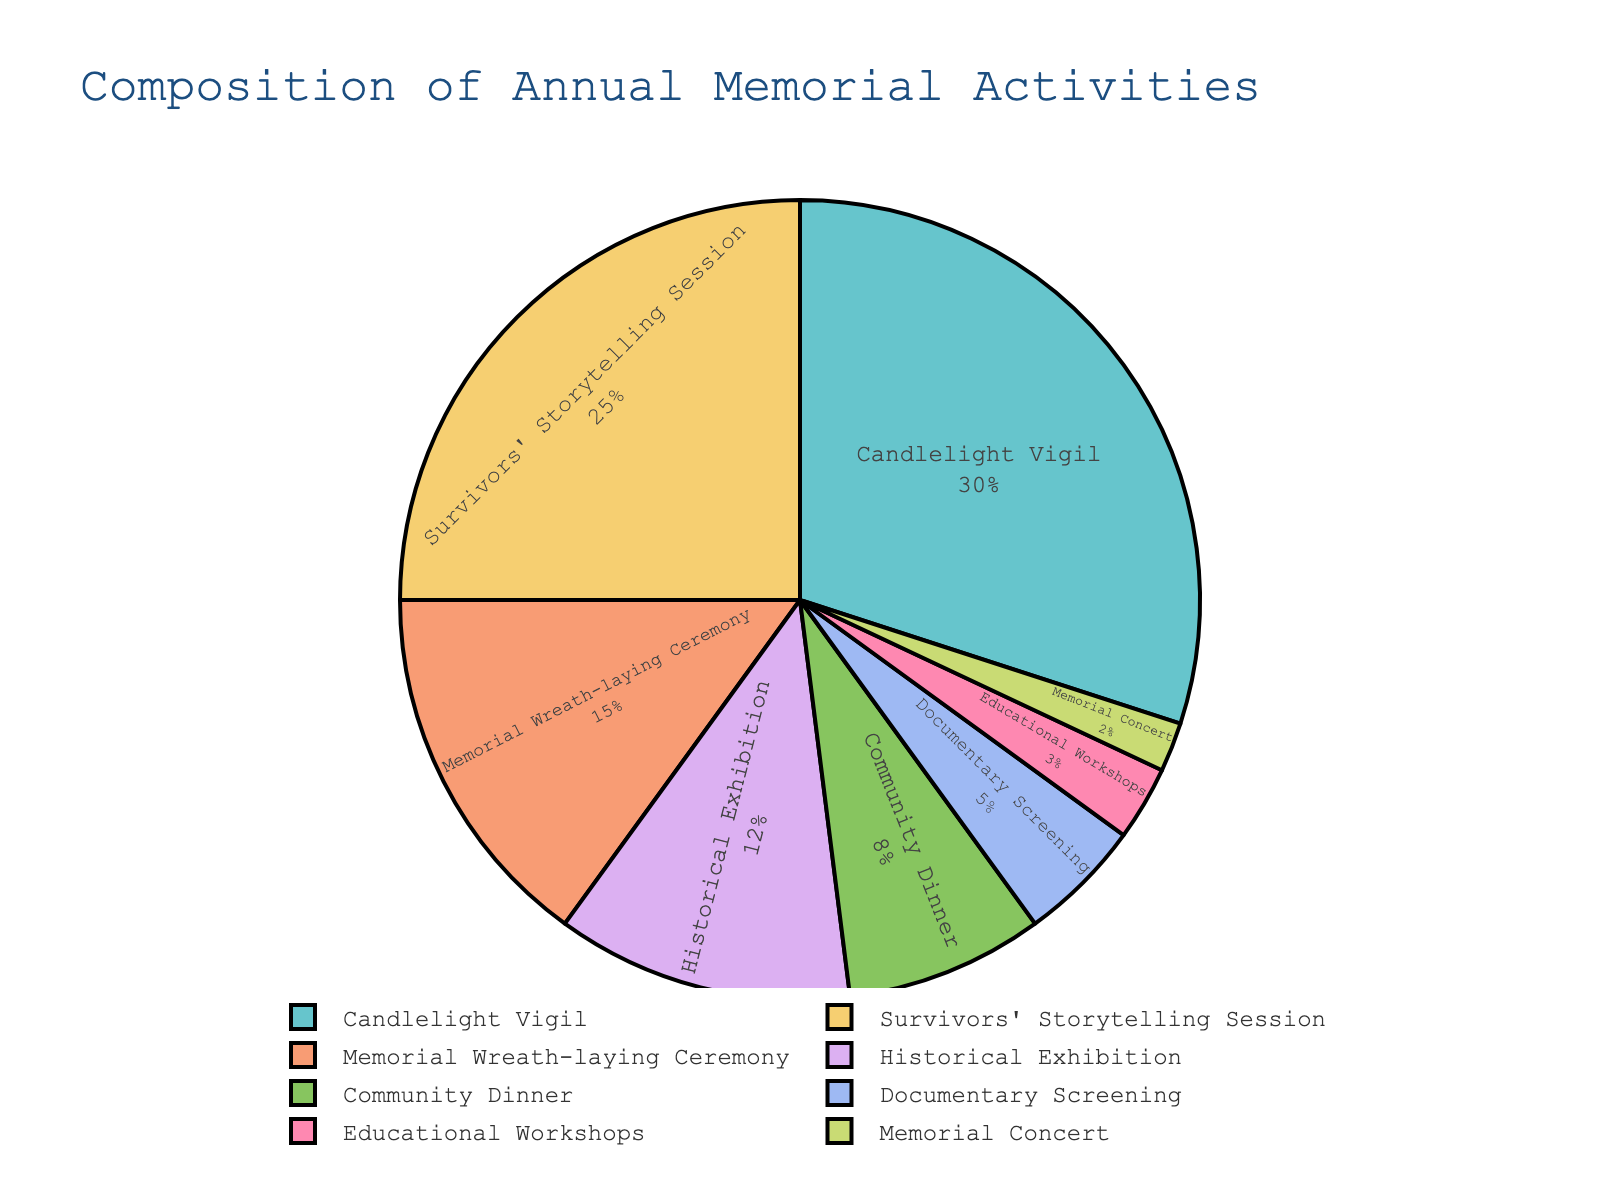Which event takes up the largest proportion of the memorial activities? According to the pie chart, the activity with the largest segment is the Candlelight Vigil. It occupies the largest visual portion, indicated by its 30% share.
Answer: Candlelight Vigil What is the combined percentage of the Memorial Wreath-laying Ceremony and the Historical Exhibition? Memorial Wreath-laying Ceremony accounts for 15% and Historical Exhibition accounts for 12%. Adding these together, 15% + 12% equals 27%.
Answer: 27% Compare the percentage contributions of the Community Dinner and the Documentary Screening. Which one is larger and by how much? Community Dinner contributes 8% while Documentary Screening contributes 5%. The difference between them is 8% - 5% = 3%.
Answer: Community Dinner by 3% What is the total percentage of activities that involve storytelling or exhibitions? Adding the percentage of the Survivors' Storytelling Session (25%) and Historical Exhibition (12%), 25% + 12% = 37%.
Answer: 37% How much smaller is the percentage for Educational Workshops compared to the Survivors' Storytelling Session? Survivors' Storytelling Session is at 25% while Educational Workshops is at 3%. The difference is 25% - 3% = 22%.
Answer: 22% Which visual segment represents the smallest proportion of activities? The segment representing Memorial Concert is the smallest, indicated by its 2% share.
Answer: Memorial Concert How do the percentages of Candlelight Vigil and Educational Workshops compare? Candlelight Vigil has a percentage of 30% while Educational Workshops has 3%. Candlelight Vigil is significantly larger, specifically 30% - 3% = 27% larger.
Answer: Candlelight Vigil by 27% Determine the combined percentage of all activities that make up less than 10% each. Summing up the percentages of Community Dinner (8%), Documentary Screening (5%), Educational Workshops (3%), and Memorial Concert (2%): 8% + 5% + 3% + 2% = 18%.
Answer: 18% How many activities comprise the top three largest proportions? The top three activities are Candlelight Vigil (30%), Survivors' Storytelling Session (25%), and Memorial Wreath-laying Ceremony (15%), totaling three activities.
Answer: 3 